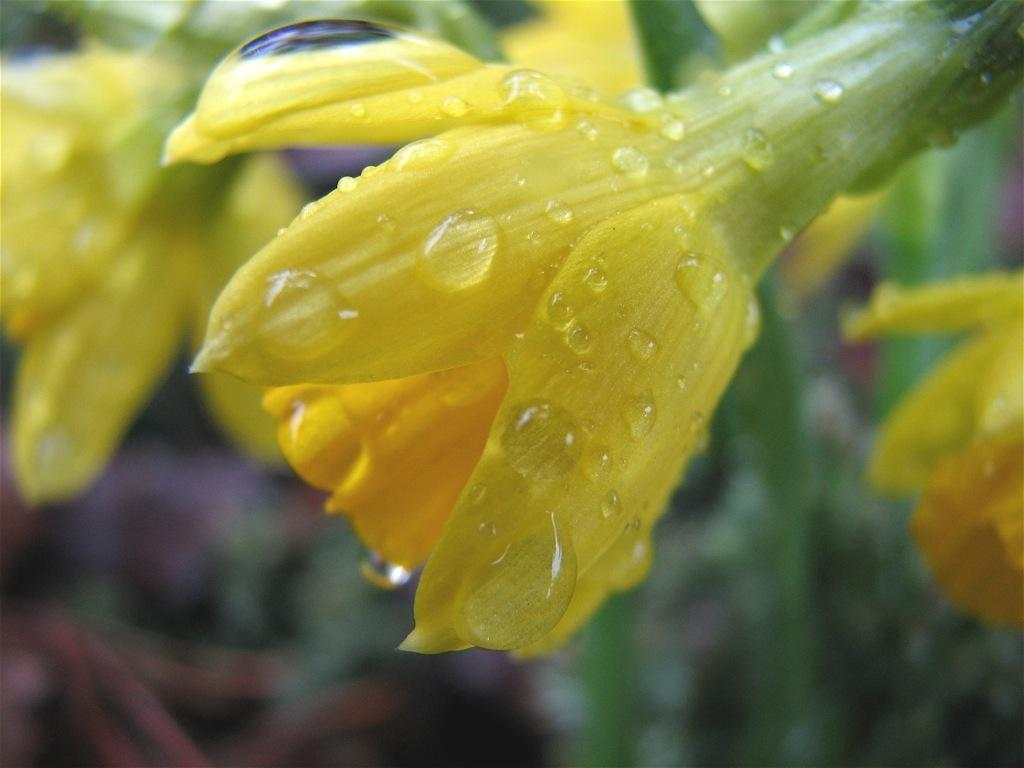What type of flowers are present in the image? There are yellow flowers in the image. What can be seen in the background of the image? The background of the image includes leaves. How would you describe the clarity of the image? The image is blurry. What type of van can be seen in the image? There is no van present in the image; it only features yellow flowers and leaves in the background. 